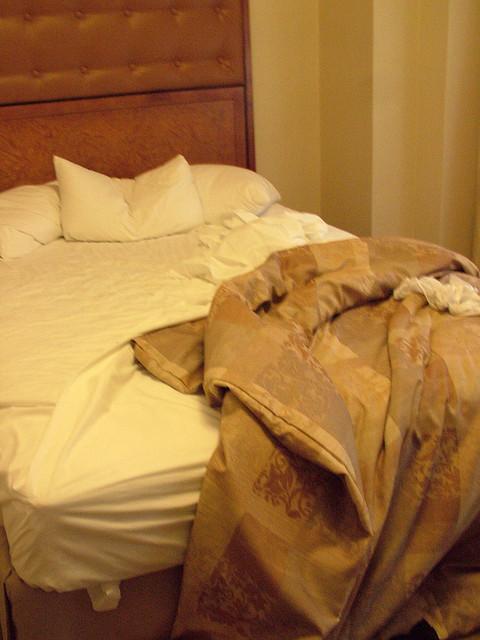How many pillows are on this bed?
Give a very brief answer. 3. How many people are wearing a orange shirt?
Give a very brief answer. 0. 